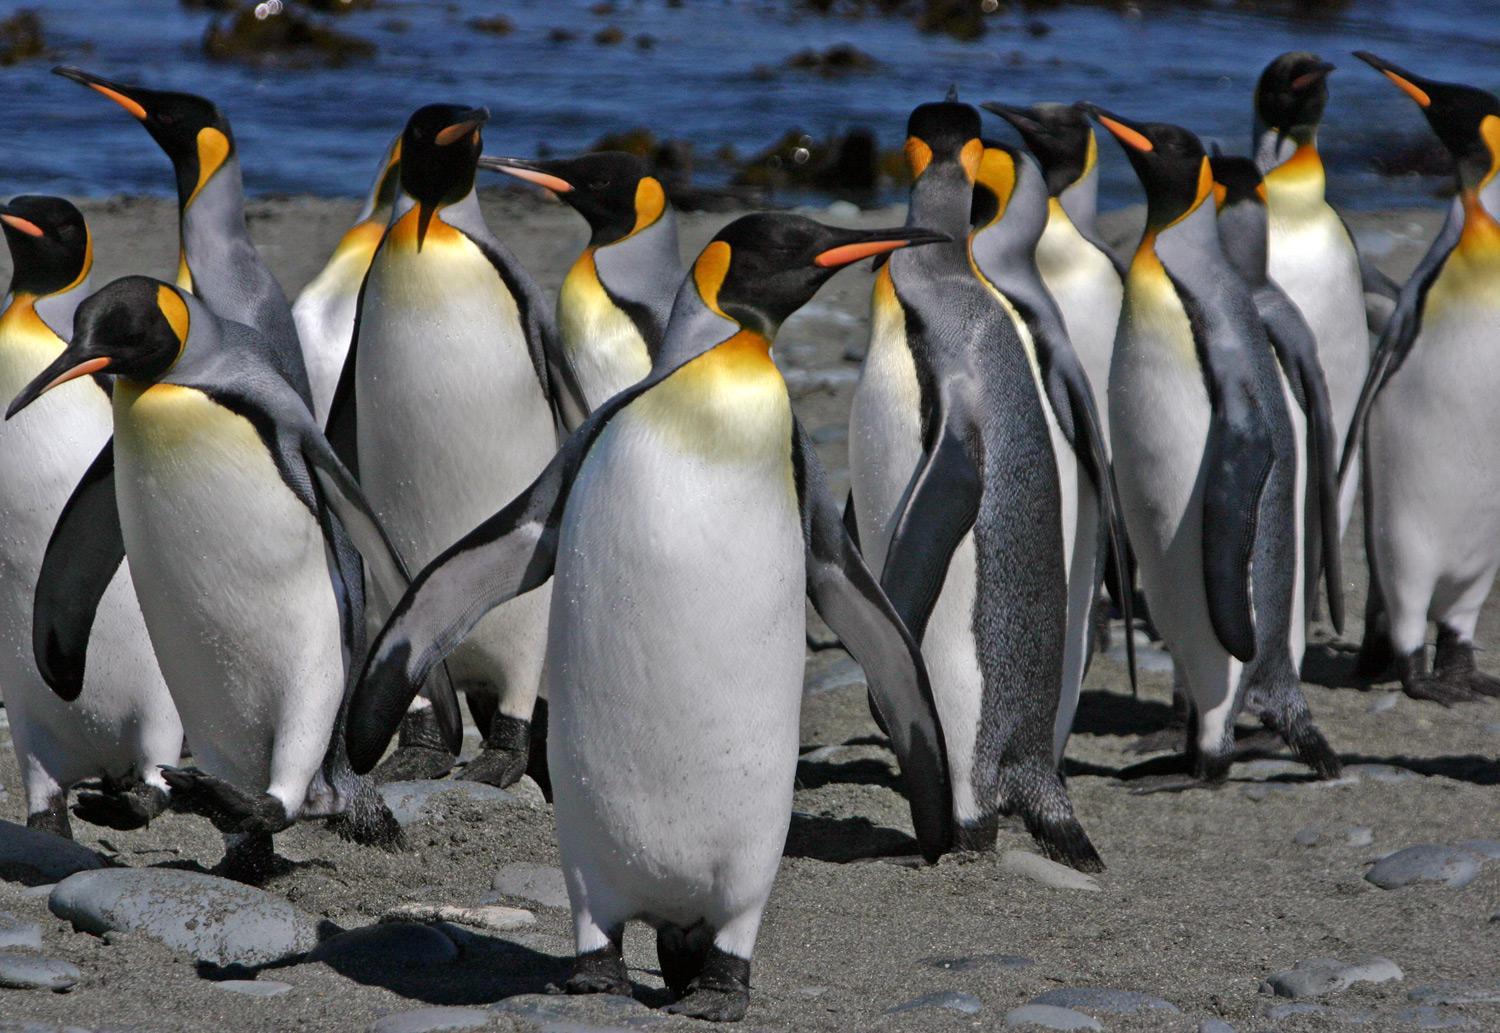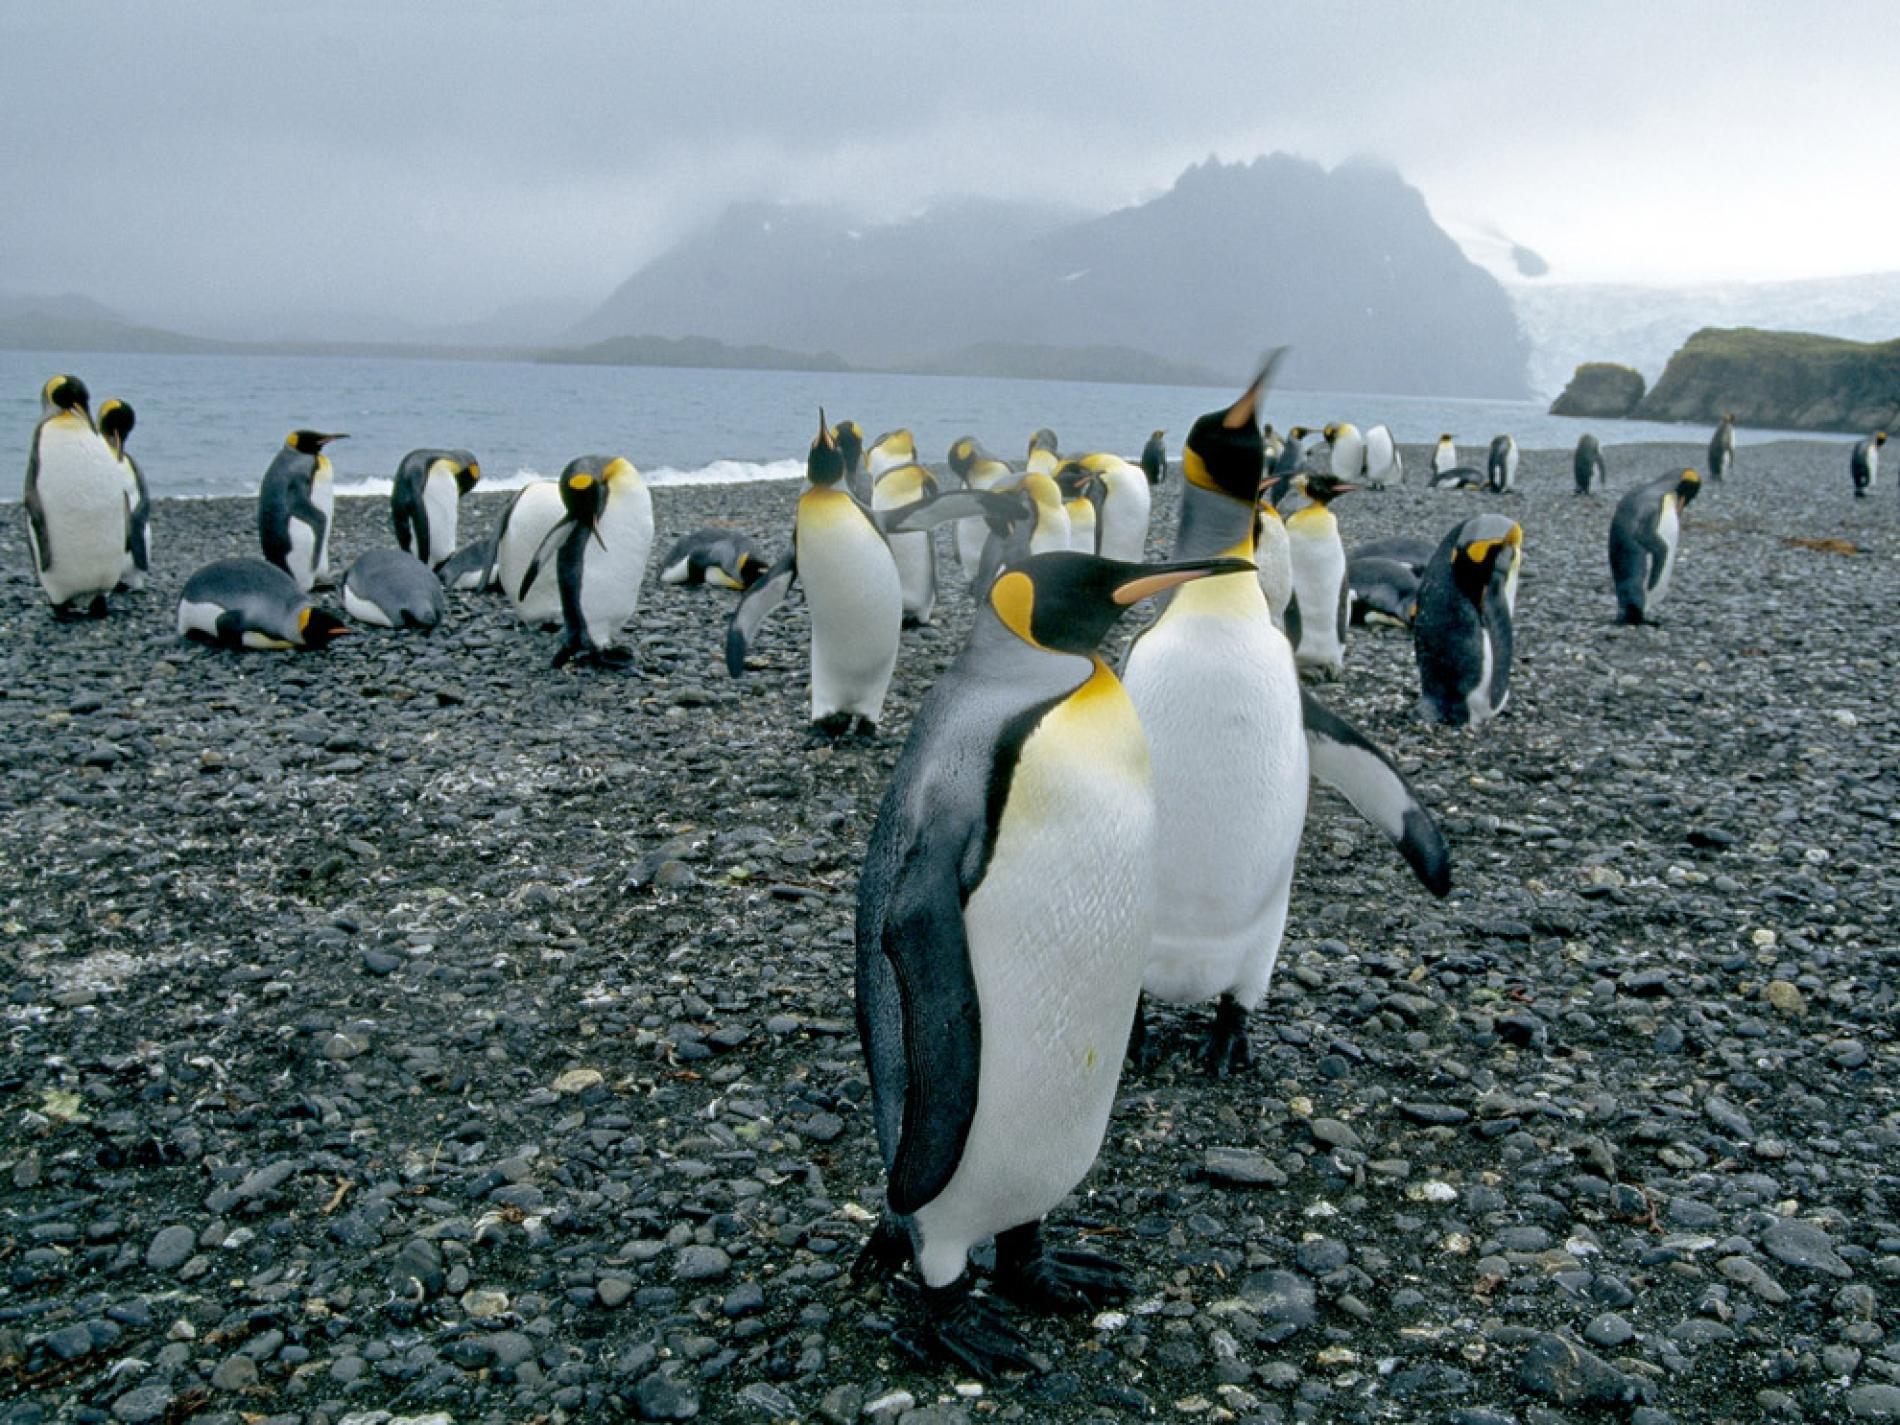The first image is the image on the left, the second image is the image on the right. For the images displayed, is the sentence "There are two penguins standing together in the left image." factually correct? Answer yes or no. No. The first image is the image on the left, the second image is the image on the right. Considering the images on both sides, is "There is at least one image containing only two penguins." valid? Answer yes or no. No. 